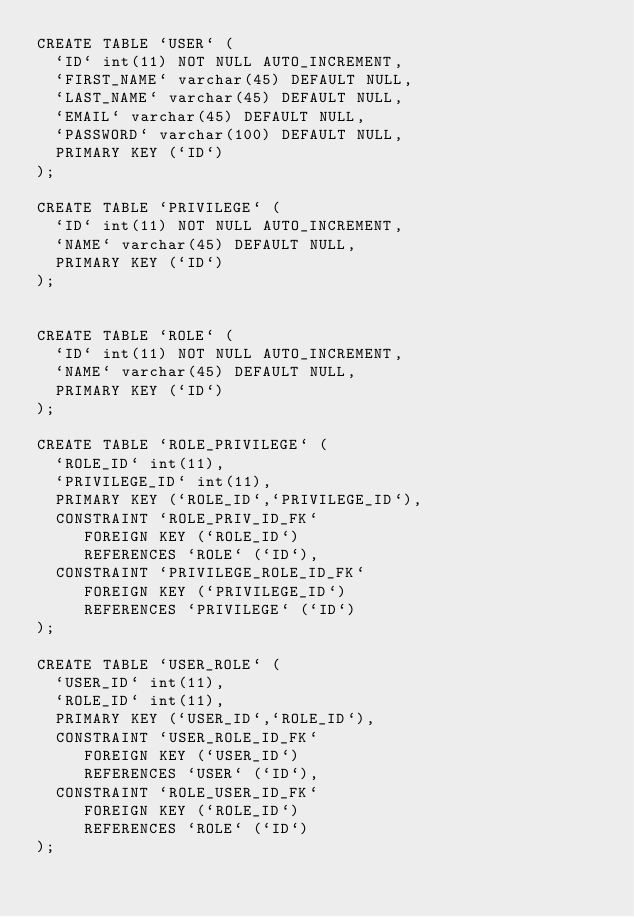Convert code to text. <code><loc_0><loc_0><loc_500><loc_500><_SQL_>CREATE TABLE `USER` (
  `ID` int(11) NOT NULL AUTO_INCREMENT,
  `FIRST_NAME` varchar(45) DEFAULT NULL,
  `LAST_NAME` varchar(45) DEFAULT NULL,
  `EMAIL` varchar(45) DEFAULT NULL,
  `PASSWORD` varchar(100) DEFAULT NULL,
  PRIMARY KEY (`ID`)
);

CREATE TABLE `PRIVILEGE` (
  `ID` int(11) NOT NULL AUTO_INCREMENT,
  `NAME` varchar(45) DEFAULT NULL,
  PRIMARY KEY (`ID`)
);


CREATE TABLE `ROLE` (
  `ID` int(11) NOT NULL AUTO_INCREMENT,
  `NAME` varchar(45) DEFAULT NULL,
  PRIMARY KEY (`ID`)
);

CREATE TABLE `ROLE_PRIVILEGE` (
  `ROLE_ID` int(11),
  `PRIVILEGE_ID` int(11),
  PRIMARY KEY (`ROLE_ID`,`PRIVILEGE_ID`),
  CONSTRAINT `ROLE_PRIV_ID_FK` 
     FOREIGN KEY (`ROLE_ID`) 
     REFERENCES `ROLE` (`ID`),
  CONSTRAINT `PRIVILEGE_ROLE_ID_FK` 
     FOREIGN KEY (`PRIVILEGE_ID`) 
     REFERENCES `PRIVILEGE` (`ID`)
);

CREATE TABLE `USER_ROLE` (
  `USER_ID` int(11),
  `ROLE_ID` int(11),
  PRIMARY KEY (`USER_ID`,`ROLE_ID`),
  CONSTRAINT `USER_ROLE_ID_FK` 
     FOREIGN KEY (`USER_ID`) 
     REFERENCES `USER` (`ID`),
  CONSTRAINT `ROLE_USER_ID_FK` 
     FOREIGN KEY (`ROLE_ID`) 
     REFERENCES `ROLE` (`ID`)
);


</code> 